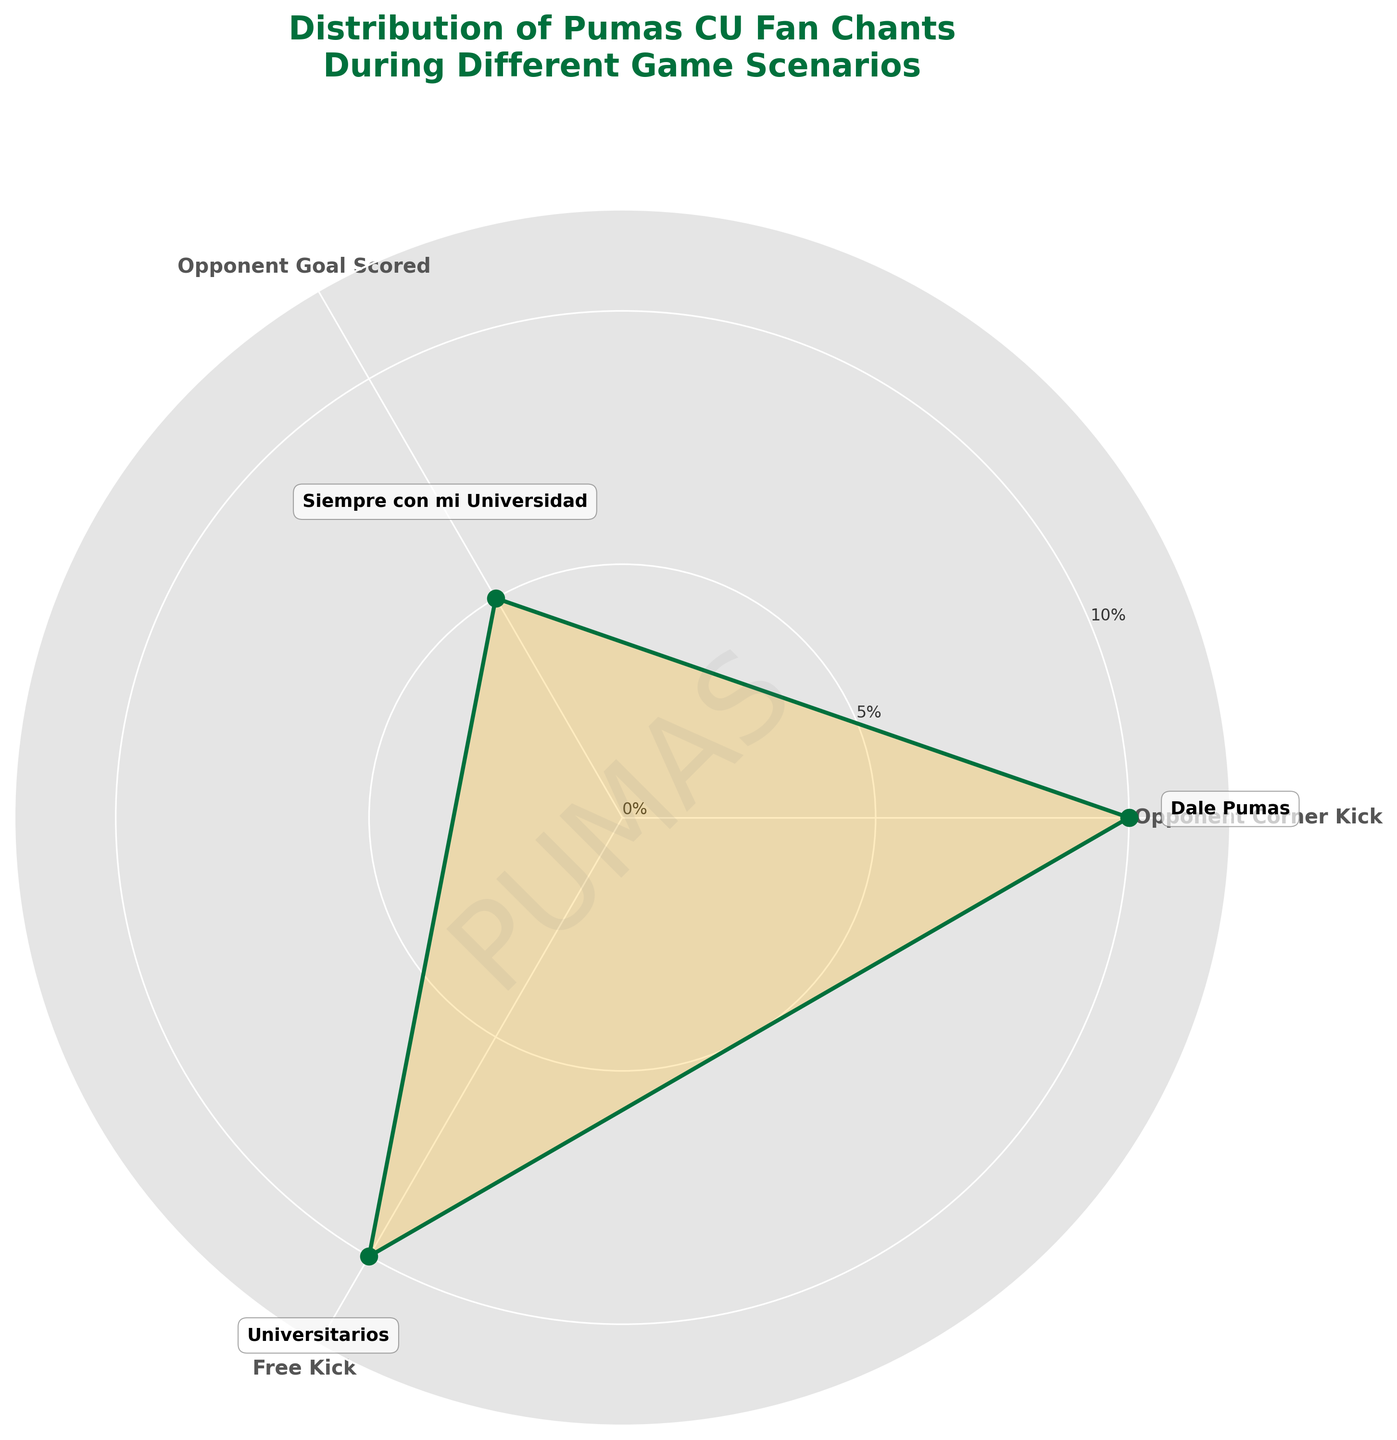What is the title of the chart? The title of the chart is located at the top. It reads "Distribution of Pumas CU Fan Chants During Different Game Scenarios"
Answer: Distribution of Pumas CU Fan Chants During Different Game Scenarios What color is used for the outer curve of the rose chart? The outer curve of the rose chart is the line that goes around the filled area. It is colored green.
Answer: Green Which chant is used during an opponent’s goal scored? By looking at the annotations on the chart, during an opponent’s goal scored, the chant "Siempre con mi Universidad" is used.
Answer: Siempre con mi Universidad What is the y-axis limit in the chart? The y-axis limit is indicated by the vertical alignment of the ticks. The highest value shown on the y-axis is 12%.
Answer: 12% What is the total percentage of chants used during 'Opponent Corner Kick' and 'Free Kick'? Summing the percentages provided for 'Opponent Corner Kick' (10%) and 'Free Kick' (10%) gives 10 + 10 = 20%
Answer: 20% Which game scenario has the smallest percentage of chants? By reviewing the percentages for each scenario, the 'Opponent Goal Scored' scenario has the smallest percentage at 5%.
Answer: Opponent Goal Scored How does the chant usage during 'Free Kick' compare to 'Opponent Corner Kick'? Comparing the percentages, both 'Free Kick' and 'Opponent Corner Kick' have 10% chant usage, meaning they are equal.
Answer: Equal If we were to combine the usage of "Universitarios" and "Dale Pumas", what proportion of the total chants do they represent? Adding the percentages for "Free Kick" (10%) and "Opponent Corner Kick" (10%) gives 10 + 10 = 20%. Since the total is 100%, the proportion is 20%.
Answer: 20% What chant is most commonly associated with "Opponent Corner Kick"? Examining the labeled annotations at 'Opponent Corner Kick', the chant associated is "Dale Pumas".
Answer: Dale Pumas 